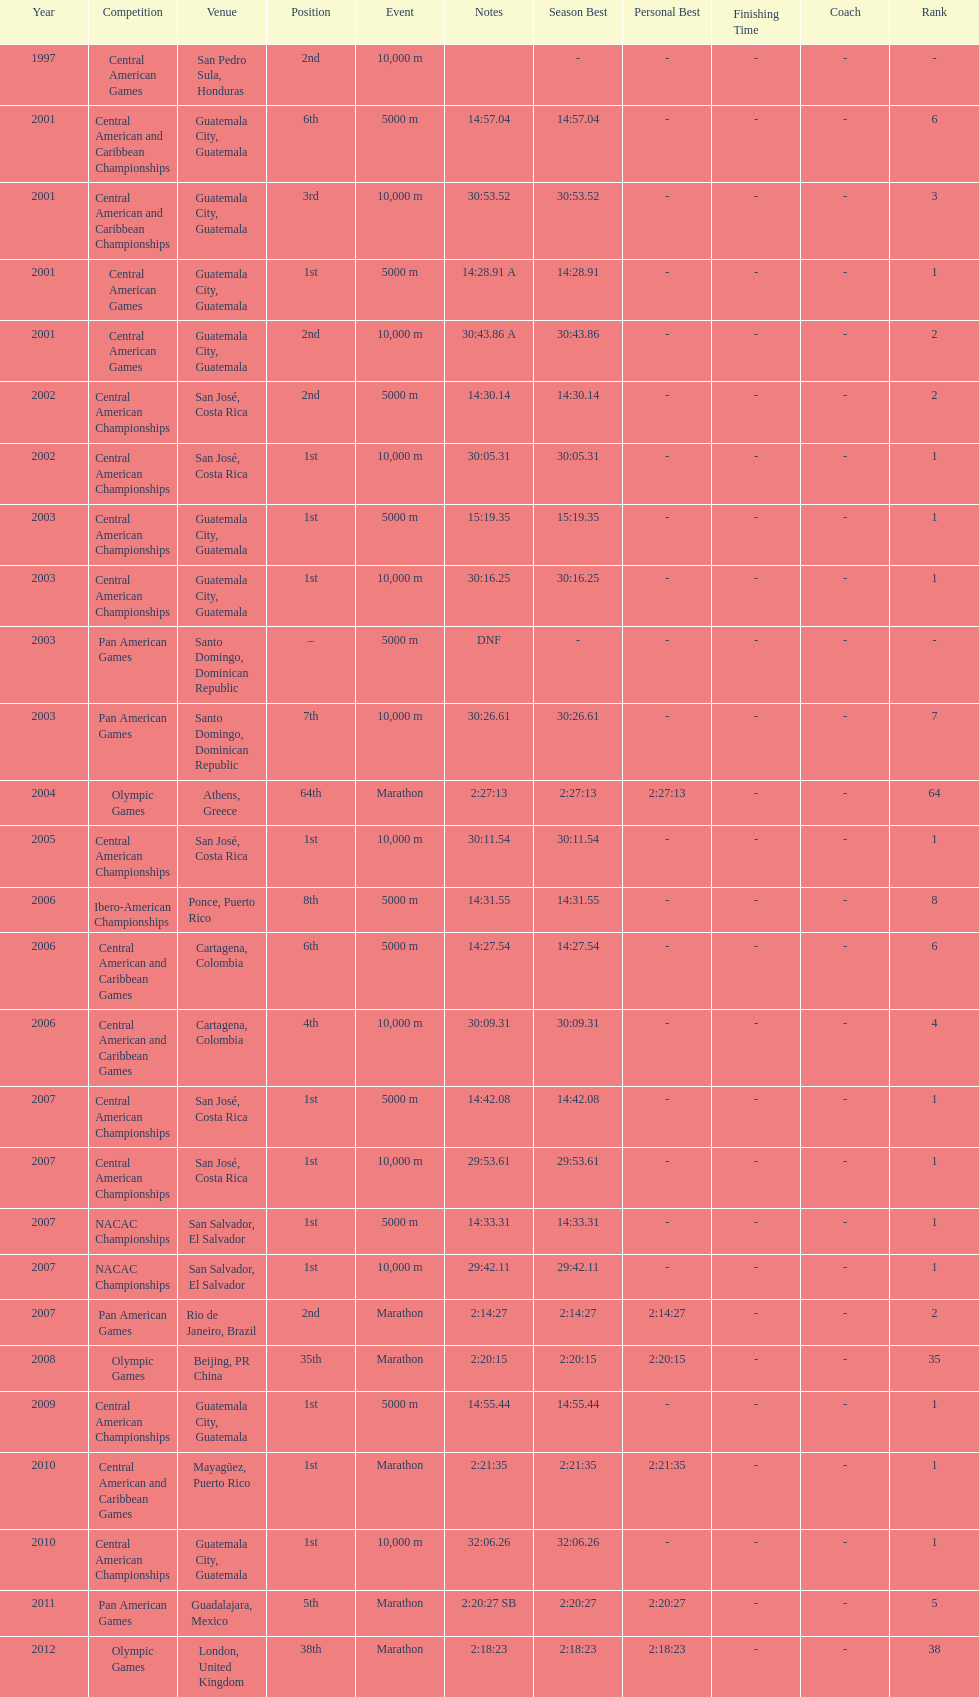The central american championships and what other competition occurred in 2010? Central American and Caribbean Games. 